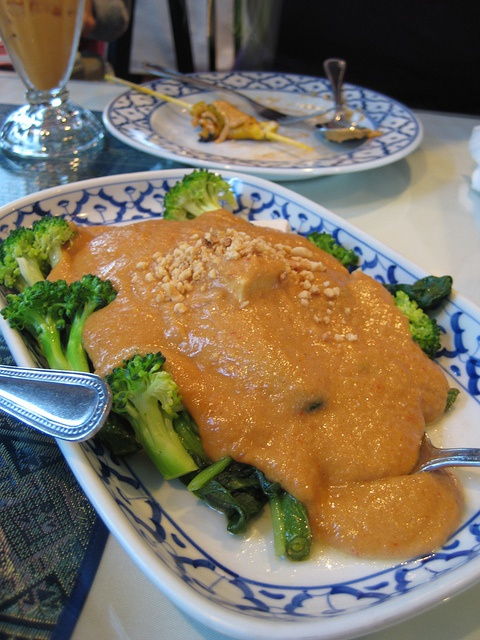Describe the objects in this image and their specific colors. I can see dining table in orange, olive, darkgray, black, and gray tones, bowl in olive, orange, darkgray, tan, and black tones, cup in olive, maroon, gray, and white tones, fork in olive, white, lightblue, and gray tones, and broccoli in olive, darkgreen, black, and green tones in this image. 